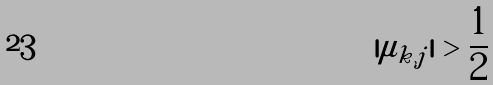<formula> <loc_0><loc_0><loc_500><loc_500>| \mu _ { k , j } | > \frac { 1 } { 2 }</formula> 